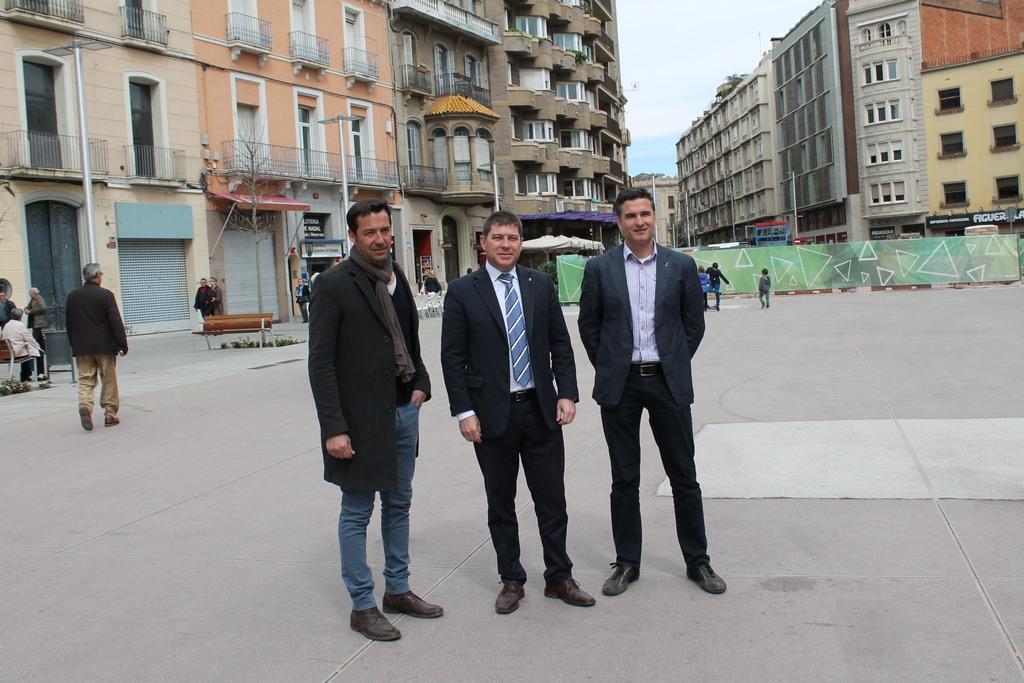Can you describe this image briefly? This is an outside view. Here I can see three men are standing on the ground, smiling and giving pose for the picture. On the left side few people are walking on the ground. In the background there are few buildings. At the top, I can see the sky. 